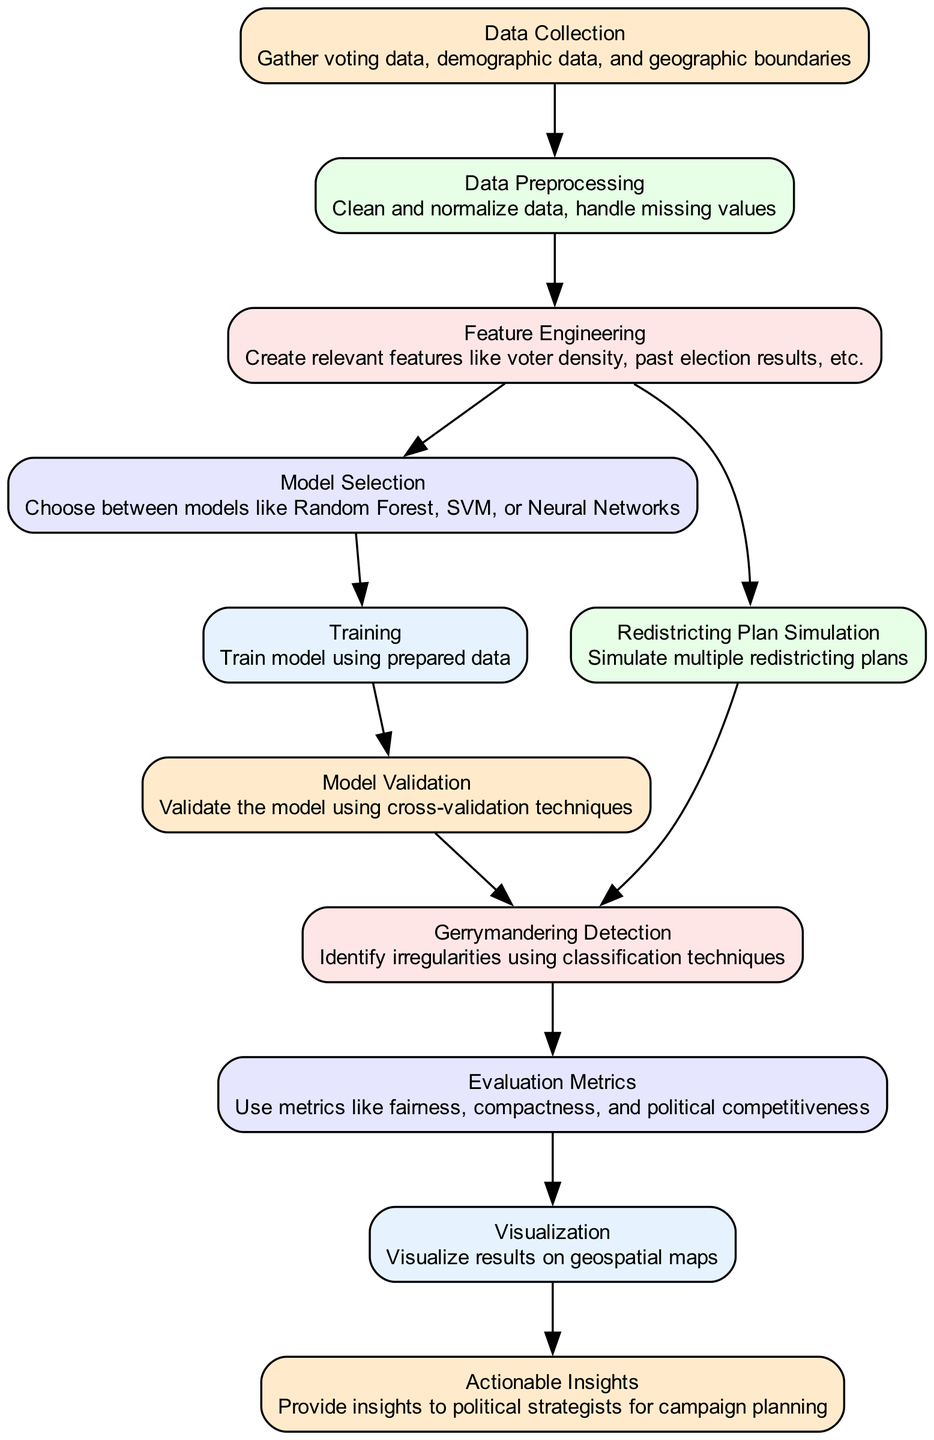What is the first step in the machine learning process? According to the diagram, the first step is "Data Collection," which involves gathering voting data, demographic data, and geographic boundaries.
Answer: Data Collection How many nodes are in the diagram? By counting all the nodes represented in the diagram, we see there are 11 distinct nodes.
Answer: 11 Which model is mentioned for selection? The diagram specifies the need for "Model Selection," with options including Random Forest, SVM, or Neural Networks.
Answer: Random Forest, SVM, or Neural Networks What is the purpose of the "Visualization" node? The "Visualization" node aims to visualize results on geospatial maps. This insight assists in understanding the spatial implications of the analysis performed.
Answer: Visualize results on geospatial maps How do you validate the model? "Model Validation" is performed using cross-validation techniques, ensuring the model's robustness and reliability in making predictions.
Answer: Cross-validation techniques Which step leads to actionable insights? The final step in that path, after "Visualization," leads to the node labeled "Actionable Insights," which offers insights to political strategists for campaign planning.
Answer: Actionable Insights How are irregularities identified in redistricting plans? The node "Gerrymandering Detection" identifies irregularities using classification techniques, which help pinpoint discrepancies in the redistricting processes.
Answer: Classification techniques What metrics are used to evaluate the redistricting plans? The "Evaluation Metrics" node states that fairness, compactness, and political competitiveness are metrics utilized to assess the quality of the redistricting plans.
Answer: Fairness, compactness, and political competitiveness Which process involves simulating redistricting plans? The process referred to in the diagram is "Redistricting Plan Simulation," signifying the exploration of various potential district layouts.
Answer: Redistricting Plan Simulation 